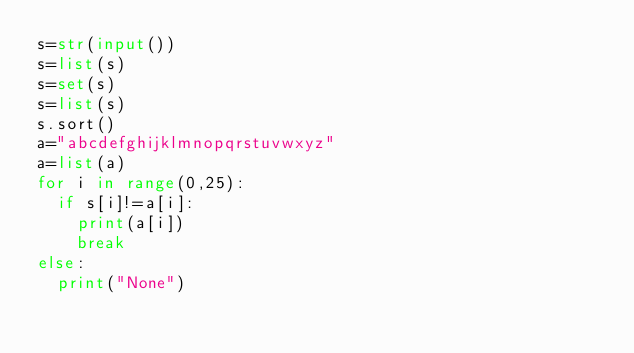<code> <loc_0><loc_0><loc_500><loc_500><_Python_>s=str(input())
s=list(s)
s=set(s)
s=list(s)
s.sort()
a="abcdefghijklmnopqrstuvwxyz"
a=list(a)
for i in range(0,25):
  if s[i]!=a[i]:
    print(a[i])
    break
else:
  print("None")
</code> 